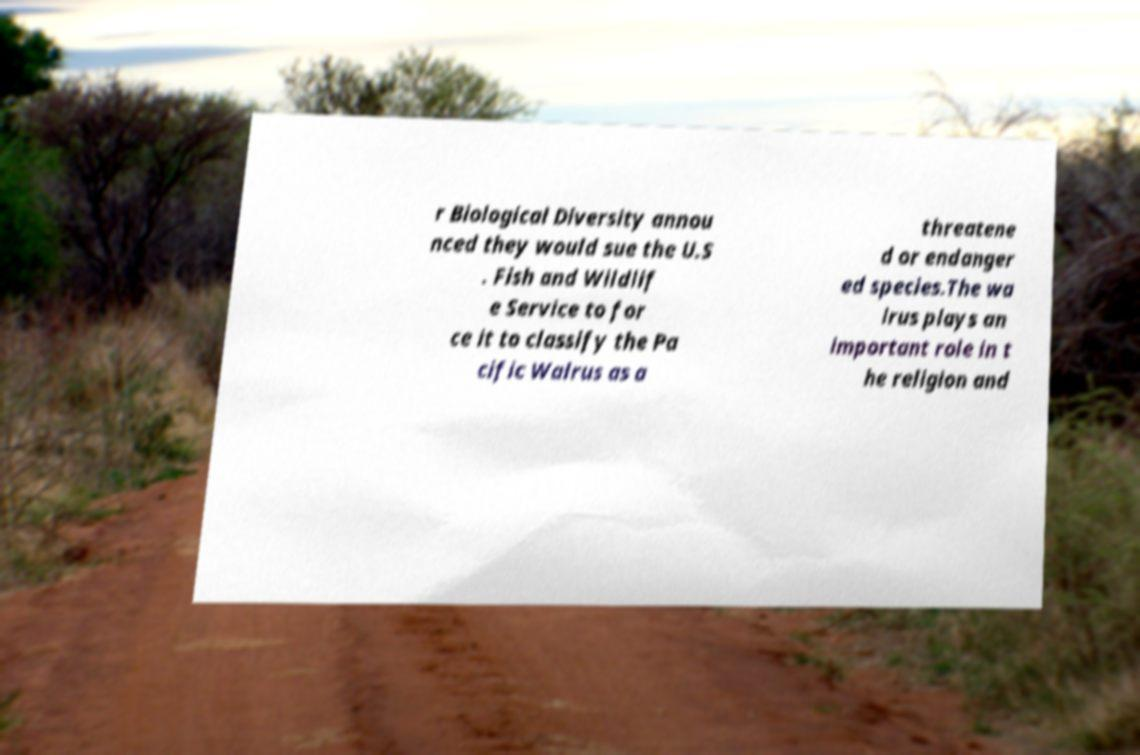Please read and relay the text visible in this image. What does it say? r Biological Diversity annou nced they would sue the U.S . Fish and Wildlif e Service to for ce it to classify the Pa cific Walrus as a threatene d or endanger ed species.The wa lrus plays an important role in t he religion and 